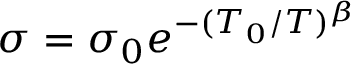<formula> <loc_0><loc_0><loc_500><loc_500>\sigma = \sigma _ { 0 } e ^ { - ( T _ { 0 } / T ) ^ { \beta } }</formula> 